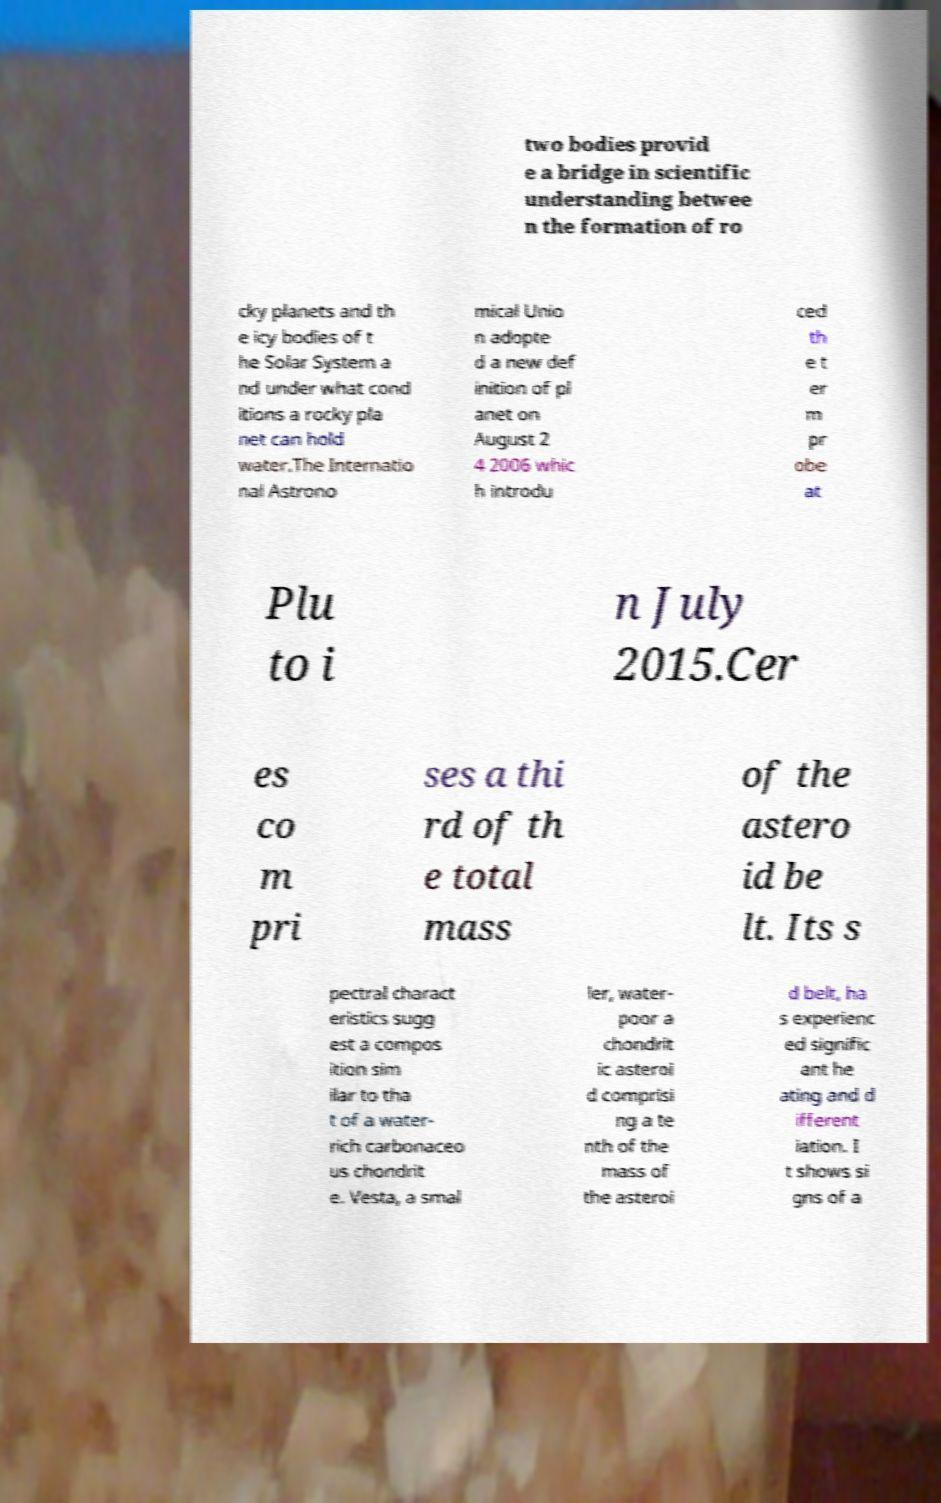Can you read and provide the text displayed in the image?This photo seems to have some interesting text. Can you extract and type it out for me? two bodies provid e a bridge in scientific understanding betwee n the formation of ro cky planets and th e icy bodies of t he Solar System a nd under what cond itions a rocky pla net can hold water.The Internatio nal Astrono mical Unio n adopte d a new def inition of pl anet on August 2 4 2006 whic h introdu ced th e t er m pr obe at Plu to i n July 2015.Cer es co m pri ses a thi rd of th e total mass of the astero id be lt. Its s pectral charact eristics sugg est a compos ition sim ilar to tha t of a water- rich carbonaceo us chondrit e. Vesta, a smal ler, water- poor a chondrit ic asteroi d comprisi ng a te nth of the mass of the asteroi d belt, ha s experienc ed signific ant he ating and d ifferent iation. I t shows si gns of a 